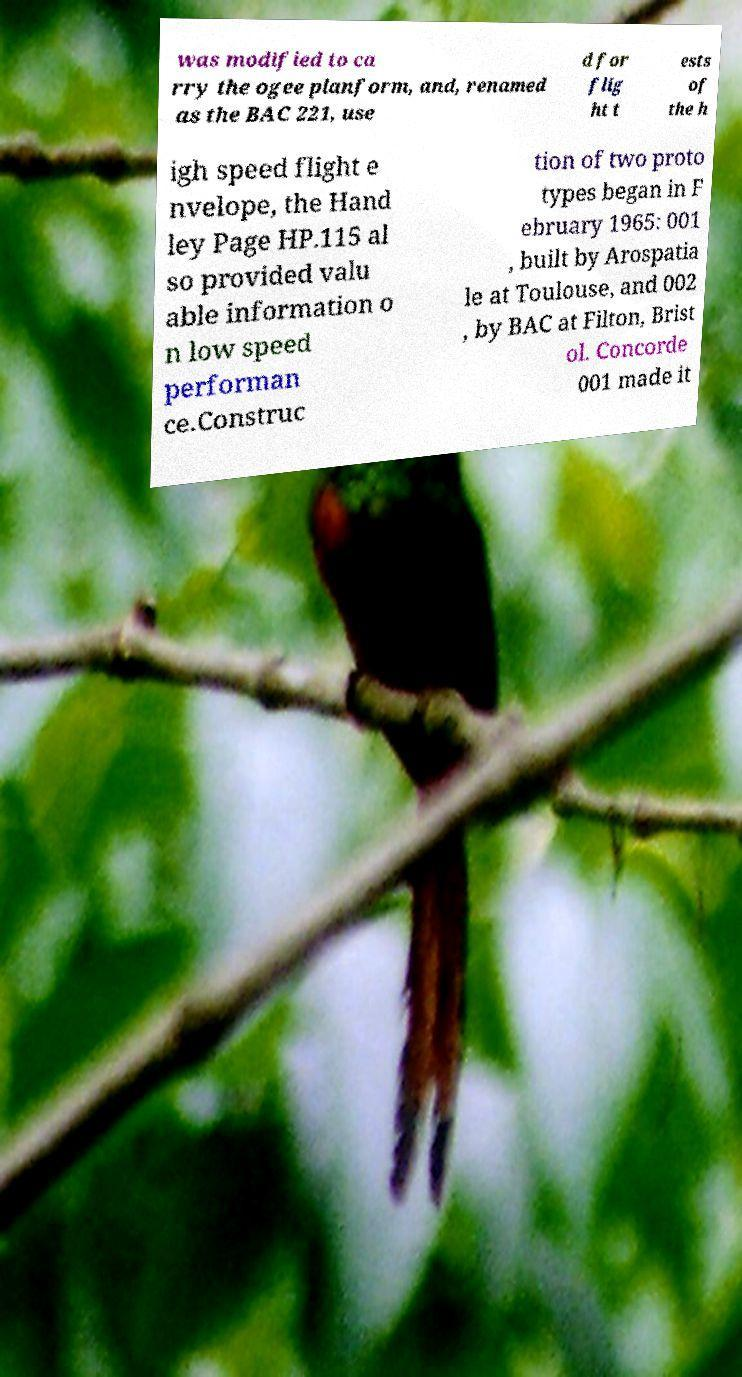What messages or text are displayed in this image? I need them in a readable, typed format. was modified to ca rry the ogee planform, and, renamed as the BAC 221, use d for flig ht t ests of the h igh speed flight e nvelope, the Hand ley Page HP.115 al so provided valu able information o n low speed performan ce.Construc tion of two proto types began in F ebruary 1965: 001 , built by Arospatia le at Toulouse, and 002 , by BAC at Filton, Brist ol. Concorde 001 made it 